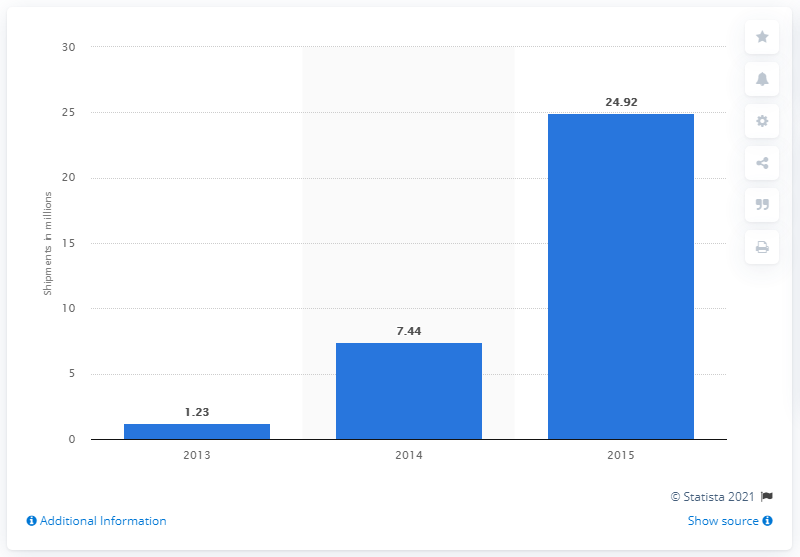Highlight a few significant elements in this photo. According to the forecast, it is expected that 24.92 units of smart watches will be shipped in 2015. 